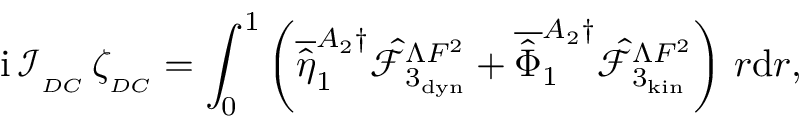Convert formula to latex. <formula><loc_0><loc_0><loc_500><loc_500>i \, \mathcal { I } _ { _ { D C } } \, \zeta _ { _ { D C } } = \int _ { 0 } ^ { 1 } \left ( \overline { { \hat { \eta } } } _ { 1 } ^ { A _ { 2 } \dagger } \hat { \mathcal { F } } _ { 3 _ { d y n } } ^ { \Lambda F ^ { 2 } } + \overline { { \hat { \Phi } } } _ { 1 } ^ { A _ { 2 } \dagger } \hat { \mathcal { F } } _ { 3 _ { k i n } } ^ { \Lambda F ^ { 2 } } \right ) \, r d r ,</formula> 